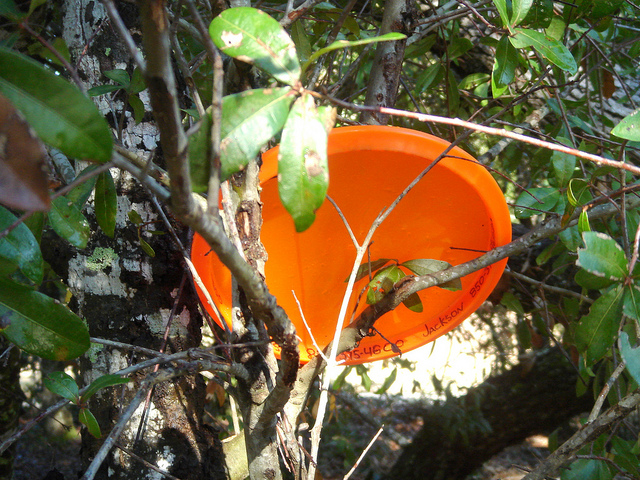Read and extract the text from this image. JACKSON 